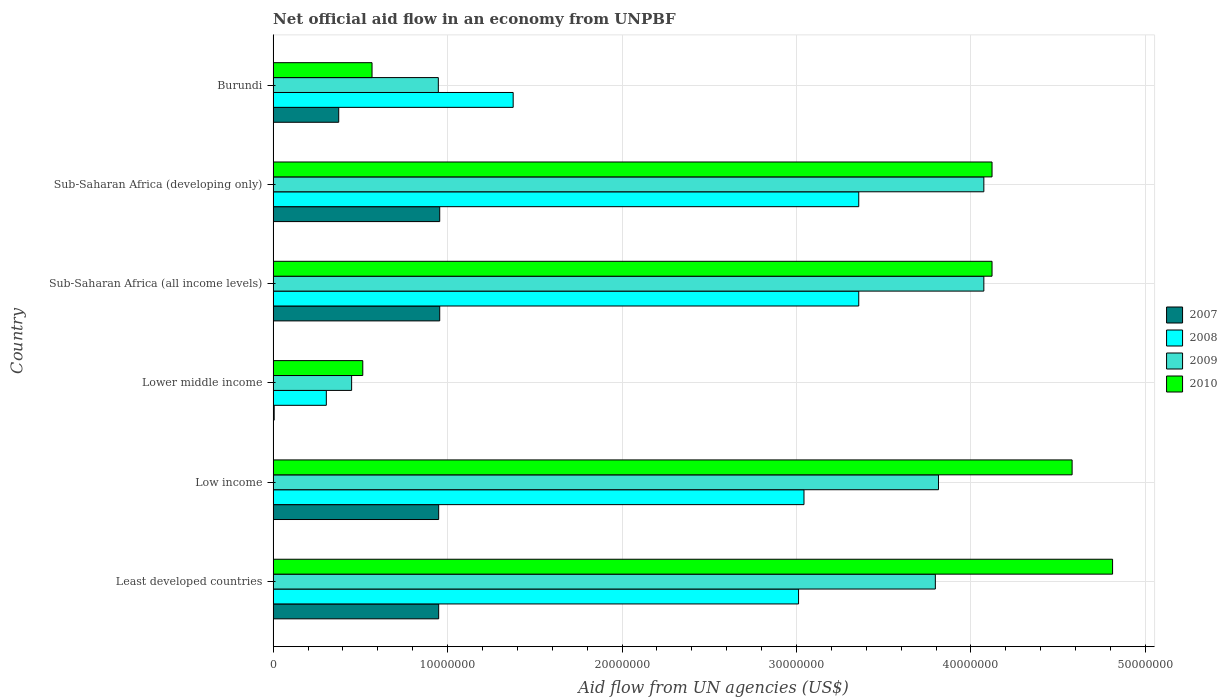What is the label of the 1st group of bars from the top?
Give a very brief answer. Burundi. In how many cases, is the number of bars for a given country not equal to the number of legend labels?
Ensure brevity in your answer.  0. What is the net official aid flow in 2007 in Lower middle income?
Make the answer very short. 6.00e+04. Across all countries, what is the maximum net official aid flow in 2010?
Your answer should be compact. 4.81e+07. Across all countries, what is the minimum net official aid flow in 2008?
Offer a very short reply. 3.05e+06. In which country was the net official aid flow in 2008 maximum?
Offer a very short reply. Sub-Saharan Africa (all income levels). In which country was the net official aid flow in 2008 minimum?
Provide a succinct answer. Lower middle income. What is the total net official aid flow in 2009 in the graph?
Ensure brevity in your answer.  1.72e+08. What is the difference between the net official aid flow in 2007 in Least developed countries and that in Low income?
Provide a succinct answer. 0. What is the difference between the net official aid flow in 2009 in Burundi and the net official aid flow in 2010 in Low income?
Keep it short and to the point. -3.63e+07. What is the average net official aid flow in 2008 per country?
Make the answer very short. 2.41e+07. What is the difference between the net official aid flow in 2010 and net official aid flow in 2008 in Sub-Saharan Africa (developing only)?
Make the answer very short. 7.64e+06. In how many countries, is the net official aid flow in 2007 greater than 48000000 US$?
Your answer should be very brief. 0. What is the ratio of the net official aid flow in 2010 in Low income to that in Sub-Saharan Africa (all income levels)?
Keep it short and to the point. 1.11. Is the difference between the net official aid flow in 2010 in Low income and Sub-Saharan Africa (developing only) greater than the difference between the net official aid flow in 2008 in Low income and Sub-Saharan Africa (developing only)?
Your answer should be very brief. Yes. What is the difference between the highest and the lowest net official aid flow in 2009?
Your answer should be compact. 3.62e+07. How many bars are there?
Your answer should be compact. 24. Are all the bars in the graph horizontal?
Provide a succinct answer. Yes. How many countries are there in the graph?
Make the answer very short. 6. Are the values on the major ticks of X-axis written in scientific E-notation?
Offer a very short reply. No. Does the graph contain grids?
Ensure brevity in your answer.  Yes. How many legend labels are there?
Provide a succinct answer. 4. How are the legend labels stacked?
Provide a short and direct response. Vertical. What is the title of the graph?
Give a very brief answer. Net official aid flow in an economy from UNPBF. Does "1981" appear as one of the legend labels in the graph?
Make the answer very short. No. What is the label or title of the X-axis?
Keep it short and to the point. Aid flow from UN agencies (US$). What is the Aid flow from UN agencies (US$) in 2007 in Least developed countries?
Keep it short and to the point. 9.49e+06. What is the Aid flow from UN agencies (US$) of 2008 in Least developed countries?
Your answer should be very brief. 3.01e+07. What is the Aid flow from UN agencies (US$) of 2009 in Least developed countries?
Make the answer very short. 3.80e+07. What is the Aid flow from UN agencies (US$) in 2010 in Least developed countries?
Ensure brevity in your answer.  4.81e+07. What is the Aid flow from UN agencies (US$) in 2007 in Low income?
Offer a very short reply. 9.49e+06. What is the Aid flow from UN agencies (US$) in 2008 in Low income?
Your answer should be compact. 3.04e+07. What is the Aid flow from UN agencies (US$) in 2009 in Low income?
Your answer should be very brief. 3.81e+07. What is the Aid flow from UN agencies (US$) in 2010 in Low income?
Offer a very short reply. 4.58e+07. What is the Aid flow from UN agencies (US$) in 2007 in Lower middle income?
Your response must be concise. 6.00e+04. What is the Aid flow from UN agencies (US$) in 2008 in Lower middle income?
Your answer should be very brief. 3.05e+06. What is the Aid flow from UN agencies (US$) of 2009 in Lower middle income?
Make the answer very short. 4.50e+06. What is the Aid flow from UN agencies (US$) of 2010 in Lower middle income?
Make the answer very short. 5.14e+06. What is the Aid flow from UN agencies (US$) of 2007 in Sub-Saharan Africa (all income levels)?
Your response must be concise. 9.55e+06. What is the Aid flow from UN agencies (US$) in 2008 in Sub-Saharan Africa (all income levels)?
Your answer should be very brief. 3.36e+07. What is the Aid flow from UN agencies (US$) of 2009 in Sub-Saharan Africa (all income levels)?
Offer a very short reply. 4.07e+07. What is the Aid flow from UN agencies (US$) of 2010 in Sub-Saharan Africa (all income levels)?
Your answer should be very brief. 4.12e+07. What is the Aid flow from UN agencies (US$) in 2007 in Sub-Saharan Africa (developing only)?
Ensure brevity in your answer.  9.55e+06. What is the Aid flow from UN agencies (US$) of 2008 in Sub-Saharan Africa (developing only)?
Offer a terse response. 3.36e+07. What is the Aid flow from UN agencies (US$) of 2009 in Sub-Saharan Africa (developing only)?
Offer a terse response. 4.07e+07. What is the Aid flow from UN agencies (US$) of 2010 in Sub-Saharan Africa (developing only)?
Ensure brevity in your answer.  4.12e+07. What is the Aid flow from UN agencies (US$) of 2007 in Burundi?
Offer a very short reply. 3.76e+06. What is the Aid flow from UN agencies (US$) in 2008 in Burundi?
Offer a terse response. 1.38e+07. What is the Aid flow from UN agencies (US$) of 2009 in Burundi?
Provide a short and direct response. 9.47e+06. What is the Aid flow from UN agencies (US$) of 2010 in Burundi?
Your answer should be very brief. 5.67e+06. Across all countries, what is the maximum Aid flow from UN agencies (US$) of 2007?
Offer a very short reply. 9.55e+06. Across all countries, what is the maximum Aid flow from UN agencies (US$) of 2008?
Give a very brief answer. 3.36e+07. Across all countries, what is the maximum Aid flow from UN agencies (US$) in 2009?
Ensure brevity in your answer.  4.07e+07. Across all countries, what is the maximum Aid flow from UN agencies (US$) of 2010?
Ensure brevity in your answer.  4.81e+07. Across all countries, what is the minimum Aid flow from UN agencies (US$) of 2008?
Make the answer very short. 3.05e+06. Across all countries, what is the minimum Aid flow from UN agencies (US$) of 2009?
Your answer should be very brief. 4.50e+06. Across all countries, what is the minimum Aid flow from UN agencies (US$) of 2010?
Provide a short and direct response. 5.14e+06. What is the total Aid flow from UN agencies (US$) in 2007 in the graph?
Your answer should be very brief. 4.19e+07. What is the total Aid flow from UN agencies (US$) in 2008 in the graph?
Your response must be concise. 1.44e+08. What is the total Aid flow from UN agencies (US$) in 2009 in the graph?
Offer a very short reply. 1.72e+08. What is the total Aid flow from UN agencies (US$) in 2010 in the graph?
Provide a short and direct response. 1.87e+08. What is the difference between the Aid flow from UN agencies (US$) in 2007 in Least developed countries and that in Low income?
Make the answer very short. 0. What is the difference between the Aid flow from UN agencies (US$) in 2008 in Least developed countries and that in Low income?
Your answer should be compact. -3.10e+05. What is the difference between the Aid flow from UN agencies (US$) of 2009 in Least developed countries and that in Low income?
Give a very brief answer. -1.80e+05. What is the difference between the Aid flow from UN agencies (US$) in 2010 in Least developed countries and that in Low income?
Your response must be concise. 2.32e+06. What is the difference between the Aid flow from UN agencies (US$) in 2007 in Least developed countries and that in Lower middle income?
Your answer should be compact. 9.43e+06. What is the difference between the Aid flow from UN agencies (US$) in 2008 in Least developed countries and that in Lower middle income?
Ensure brevity in your answer.  2.71e+07. What is the difference between the Aid flow from UN agencies (US$) in 2009 in Least developed countries and that in Lower middle income?
Your response must be concise. 3.35e+07. What is the difference between the Aid flow from UN agencies (US$) in 2010 in Least developed countries and that in Lower middle income?
Give a very brief answer. 4.30e+07. What is the difference between the Aid flow from UN agencies (US$) of 2008 in Least developed countries and that in Sub-Saharan Africa (all income levels)?
Your answer should be very brief. -3.45e+06. What is the difference between the Aid flow from UN agencies (US$) of 2009 in Least developed countries and that in Sub-Saharan Africa (all income levels)?
Your response must be concise. -2.78e+06. What is the difference between the Aid flow from UN agencies (US$) of 2010 in Least developed countries and that in Sub-Saharan Africa (all income levels)?
Give a very brief answer. 6.91e+06. What is the difference between the Aid flow from UN agencies (US$) of 2007 in Least developed countries and that in Sub-Saharan Africa (developing only)?
Your answer should be compact. -6.00e+04. What is the difference between the Aid flow from UN agencies (US$) of 2008 in Least developed countries and that in Sub-Saharan Africa (developing only)?
Give a very brief answer. -3.45e+06. What is the difference between the Aid flow from UN agencies (US$) of 2009 in Least developed countries and that in Sub-Saharan Africa (developing only)?
Your answer should be very brief. -2.78e+06. What is the difference between the Aid flow from UN agencies (US$) of 2010 in Least developed countries and that in Sub-Saharan Africa (developing only)?
Make the answer very short. 6.91e+06. What is the difference between the Aid flow from UN agencies (US$) of 2007 in Least developed countries and that in Burundi?
Offer a terse response. 5.73e+06. What is the difference between the Aid flow from UN agencies (US$) of 2008 in Least developed countries and that in Burundi?
Your response must be concise. 1.64e+07. What is the difference between the Aid flow from UN agencies (US$) of 2009 in Least developed countries and that in Burundi?
Your response must be concise. 2.85e+07. What is the difference between the Aid flow from UN agencies (US$) of 2010 in Least developed countries and that in Burundi?
Make the answer very short. 4.24e+07. What is the difference between the Aid flow from UN agencies (US$) of 2007 in Low income and that in Lower middle income?
Ensure brevity in your answer.  9.43e+06. What is the difference between the Aid flow from UN agencies (US$) of 2008 in Low income and that in Lower middle income?
Give a very brief answer. 2.74e+07. What is the difference between the Aid flow from UN agencies (US$) in 2009 in Low income and that in Lower middle income?
Your response must be concise. 3.36e+07. What is the difference between the Aid flow from UN agencies (US$) in 2010 in Low income and that in Lower middle income?
Make the answer very short. 4.07e+07. What is the difference between the Aid flow from UN agencies (US$) in 2008 in Low income and that in Sub-Saharan Africa (all income levels)?
Your answer should be very brief. -3.14e+06. What is the difference between the Aid flow from UN agencies (US$) of 2009 in Low income and that in Sub-Saharan Africa (all income levels)?
Offer a very short reply. -2.60e+06. What is the difference between the Aid flow from UN agencies (US$) in 2010 in Low income and that in Sub-Saharan Africa (all income levels)?
Provide a short and direct response. 4.59e+06. What is the difference between the Aid flow from UN agencies (US$) in 2007 in Low income and that in Sub-Saharan Africa (developing only)?
Offer a terse response. -6.00e+04. What is the difference between the Aid flow from UN agencies (US$) of 2008 in Low income and that in Sub-Saharan Africa (developing only)?
Provide a short and direct response. -3.14e+06. What is the difference between the Aid flow from UN agencies (US$) of 2009 in Low income and that in Sub-Saharan Africa (developing only)?
Ensure brevity in your answer.  -2.60e+06. What is the difference between the Aid flow from UN agencies (US$) of 2010 in Low income and that in Sub-Saharan Africa (developing only)?
Your answer should be compact. 4.59e+06. What is the difference between the Aid flow from UN agencies (US$) of 2007 in Low income and that in Burundi?
Offer a terse response. 5.73e+06. What is the difference between the Aid flow from UN agencies (US$) in 2008 in Low income and that in Burundi?
Keep it short and to the point. 1.67e+07. What is the difference between the Aid flow from UN agencies (US$) of 2009 in Low income and that in Burundi?
Offer a terse response. 2.87e+07. What is the difference between the Aid flow from UN agencies (US$) in 2010 in Low income and that in Burundi?
Your response must be concise. 4.01e+07. What is the difference between the Aid flow from UN agencies (US$) in 2007 in Lower middle income and that in Sub-Saharan Africa (all income levels)?
Offer a terse response. -9.49e+06. What is the difference between the Aid flow from UN agencies (US$) of 2008 in Lower middle income and that in Sub-Saharan Africa (all income levels)?
Make the answer very short. -3.05e+07. What is the difference between the Aid flow from UN agencies (US$) of 2009 in Lower middle income and that in Sub-Saharan Africa (all income levels)?
Your response must be concise. -3.62e+07. What is the difference between the Aid flow from UN agencies (US$) in 2010 in Lower middle income and that in Sub-Saharan Africa (all income levels)?
Your answer should be very brief. -3.61e+07. What is the difference between the Aid flow from UN agencies (US$) of 2007 in Lower middle income and that in Sub-Saharan Africa (developing only)?
Keep it short and to the point. -9.49e+06. What is the difference between the Aid flow from UN agencies (US$) in 2008 in Lower middle income and that in Sub-Saharan Africa (developing only)?
Provide a succinct answer. -3.05e+07. What is the difference between the Aid flow from UN agencies (US$) of 2009 in Lower middle income and that in Sub-Saharan Africa (developing only)?
Your answer should be very brief. -3.62e+07. What is the difference between the Aid flow from UN agencies (US$) in 2010 in Lower middle income and that in Sub-Saharan Africa (developing only)?
Make the answer very short. -3.61e+07. What is the difference between the Aid flow from UN agencies (US$) of 2007 in Lower middle income and that in Burundi?
Offer a very short reply. -3.70e+06. What is the difference between the Aid flow from UN agencies (US$) of 2008 in Lower middle income and that in Burundi?
Provide a short and direct response. -1.07e+07. What is the difference between the Aid flow from UN agencies (US$) in 2009 in Lower middle income and that in Burundi?
Your response must be concise. -4.97e+06. What is the difference between the Aid flow from UN agencies (US$) of 2010 in Lower middle income and that in Burundi?
Make the answer very short. -5.30e+05. What is the difference between the Aid flow from UN agencies (US$) in 2007 in Sub-Saharan Africa (all income levels) and that in Sub-Saharan Africa (developing only)?
Offer a terse response. 0. What is the difference between the Aid flow from UN agencies (US$) of 2008 in Sub-Saharan Africa (all income levels) and that in Sub-Saharan Africa (developing only)?
Keep it short and to the point. 0. What is the difference between the Aid flow from UN agencies (US$) of 2009 in Sub-Saharan Africa (all income levels) and that in Sub-Saharan Africa (developing only)?
Provide a short and direct response. 0. What is the difference between the Aid flow from UN agencies (US$) in 2007 in Sub-Saharan Africa (all income levels) and that in Burundi?
Make the answer very short. 5.79e+06. What is the difference between the Aid flow from UN agencies (US$) in 2008 in Sub-Saharan Africa (all income levels) and that in Burundi?
Provide a succinct answer. 1.98e+07. What is the difference between the Aid flow from UN agencies (US$) in 2009 in Sub-Saharan Africa (all income levels) and that in Burundi?
Your answer should be very brief. 3.13e+07. What is the difference between the Aid flow from UN agencies (US$) of 2010 in Sub-Saharan Africa (all income levels) and that in Burundi?
Your answer should be compact. 3.55e+07. What is the difference between the Aid flow from UN agencies (US$) of 2007 in Sub-Saharan Africa (developing only) and that in Burundi?
Give a very brief answer. 5.79e+06. What is the difference between the Aid flow from UN agencies (US$) of 2008 in Sub-Saharan Africa (developing only) and that in Burundi?
Offer a very short reply. 1.98e+07. What is the difference between the Aid flow from UN agencies (US$) of 2009 in Sub-Saharan Africa (developing only) and that in Burundi?
Keep it short and to the point. 3.13e+07. What is the difference between the Aid flow from UN agencies (US$) of 2010 in Sub-Saharan Africa (developing only) and that in Burundi?
Your answer should be compact. 3.55e+07. What is the difference between the Aid flow from UN agencies (US$) of 2007 in Least developed countries and the Aid flow from UN agencies (US$) of 2008 in Low income?
Provide a short and direct response. -2.09e+07. What is the difference between the Aid flow from UN agencies (US$) in 2007 in Least developed countries and the Aid flow from UN agencies (US$) in 2009 in Low income?
Ensure brevity in your answer.  -2.86e+07. What is the difference between the Aid flow from UN agencies (US$) of 2007 in Least developed countries and the Aid flow from UN agencies (US$) of 2010 in Low income?
Provide a short and direct response. -3.63e+07. What is the difference between the Aid flow from UN agencies (US$) of 2008 in Least developed countries and the Aid flow from UN agencies (US$) of 2009 in Low income?
Make the answer very short. -8.02e+06. What is the difference between the Aid flow from UN agencies (US$) in 2008 in Least developed countries and the Aid flow from UN agencies (US$) in 2010 in Low income?
Provide a succinct answer. -1.57e+07. What is the difference between the Aid flow from UN agencies (US$) of 2009 in Least developed countries and the Aid flow from UN agencies (US$) of 2010 in Low income?
Your answer should be compact. -7.84e+06. What is the difference between the Aid flow from UN agencies (US$) of 2007 in Least developed countries and the Aid flow from UN agencies (US$) of 2008 in Lower middle income?
Keep it short and to the point. 6.44e+06. What is the difference between the Aid flow from UN agencies (US$) in 2007 in Least developed countries and the Aid flow from UN agencies (US$) in 2009 in Lower middle income?
Provide a short and direct response. 4.99e+06. What is the difference between the Aid flow from UN agencies (US$) in 2007 in Least developed countries and the Aid flow from UN agencies (US$) in 2010 in Lower middle income?
Provide a short and direct response. 4.35e+06. What is the difference between the Aid flow from UN agencies (US$) of 2008 in Least developed countries and the Aid flow from UN agencies (US$) of 2009 in Lower middle income?
Keep it short and to the point. 2.56e+07. What is the difference between the Aid flow from UN agencies (US$) in 2008 in Least developed countries and the Aid flow from UN agencies (US$) in 2010 in Lower middle income?
Provide a succinct answer. 2.50e+07. What is the difference between the Aid flow from UN agencies (US$) in 2009 in Least developed countries and the Aid flow from UN agencies (US$) in 2010 in Lower middle income?
Keep it short and to the point. 3.28e+07. What is the difference between the Aid flow from UN agencies (US$) of 2007 in Least developed countries and the Aid flow from UN agencies (US$) of 2008 in Sub-Saharan Africa (all income levels)?
Make the answer very short. -2.41e+07. What is the difference between the Aid flow from UN agencies (US$) in 2007 in Least developed countries and the Aid flow from UN agencies (US$) in 2009 in Sub-Saharan Africa (all income levels)?
Ensure brevity in your answer.  -3.12e+07. What is the difference between the Aid flow from UN agencies (US$) of 2007 in Least developed countries and the Aid flow from UN agencies (US$) of 2010 in Sub-Saharan Africa (all income levels)?
Keep it short and to the point. -3.17e+07. What is the difference between the Aid flow from UN agencies (US$) of 2008 in Least developed countries and the Aid flow from UN agencies (US$) of 2009 in Sub-Saharan Africa (all income levels)?
Your answer should be very brief. -1.06e+07. What is the difference between the Aid flow from UN agencies (US$) in 2008 in Least developed countries and the Aid flow from UN agencies (US$) in 2010 in Sub-Saharan Africa (all income levels)?
Offer a very short reply. -1.11e+07. What is the difference between the Aid flow from UN agencies (US$) of 2009 in Least developed countries and the Aid flow from UN agencies (US$) of 2010 in Sub-Saharan Africa (all income levels)?
Offer a very short reply. -3.25e+06. What is the difference between the Aid flow from UN agencies (US$) in 2007 in Least developed countries and the Aid flow from UN agencies (US$) in 2008 in Sub-Saharan Africa (developing only)?
Keep it short and to the point. -2.41e+07. What is the difference between the Aid flow from UN agencies (US$) of 2007 in Least developed countries and the Aid flow from UN agencies (US$) of 2009 in Sub-Saharan Africa (developing only)?
Ensure brevity in your answer.  -3.12e+07. What is the difference between the Aid flow from UN agencies (US$) of 2007 in Least developed countries and the Aid flow from UN agencies (US$) of 2010 in Sub-Saharan Africa (developing only)?
Your answer should be compact. -3.17e+07. What is the difference between the Aid flow from UN agencies (US$) in 2008 in Least developed countries and the Aid flow from UN agencies (US$) in 2009 in Sub-Saharan Africa (developing only)?
Offer a terse response. -1.06e+07. What is the difference between the Aid flow from UN agencies (US$) of 2008 in Least developed countries and the Aid flow from UN agencies (US$) of 2010 in Sub-Saharan Africa (developing only)?
Provide a short and direct response. -1.11e+07. What is the difference between the Aid flow from UN agencies (US$) of 2009 in Least developed countries and the Aid flow from UN agencies (US$) of 2010 in Sub-Saharan Africa (developing only)?
Give a very brief answer. -3.25e+06. What is the difference between the Aid flow from UN agencies (US$) in 2007 in Least developed countries and the Aid flow from UN agencies (US$) in 2008 in Burundi?
Your response must be concise. -4.27e+06. What is the difference between the Aid flow from UN agencies (US$) of 2007 in Least developed countries and the Aid flow from UN agencies (US$) of 2010 in Burundi?
Offer a very short reply. 3.82e+06. What is the difference between the Aid flow from UN agencies (US$) in 2008 in Least developed countries and the Aid flow from UN agencies (US$) in 2009 in Burundi?
Provide a succinct answer. 2.06e+07. What is the difference between the Aid flow from UN agencies (US$) in 2008 in Least developed countries and the Aid flow from UN agencies (US$) in 2010 in Burundi?
Make the answer very short. 2.44e+07. What is the difference between the Aid flow from UN agencies (US$) in 2009 in Least developed countries and the Aid flow from UN agencies (US$) in 2010 in Burundi?
Your answer should be compact. 3.23e+07. What is the difference between the Aid flow from UN agencies (US$) of 2007 in Low income and the Aid flow from UN agencies (US$) of 2008 in Lower middle income?
Keep it short and to the point. 6.44e+06. What is the difference between the Aid flow from UN agencies (US$) of 2007 in Low income and the Aid flow from UN agencies (US$) of 2009 in Lower middle income?
Your response must be concise. 4.99e+06. What is the difference between the Aid flow from UN agencies (US$) in 2007 in Low income and the Aid flow from UN agencies (US$) in 2010 in Lower middle income?
Give a very brief answer. 4.35e+06. What is the difference between the Aid flow from UN agencies (US$) of 2008 in Low income and the Aid flow from UN agencies (US$) of 2009 in Lower middle income?
Provide a succinct answer. 2.59e+07. What is the difference between the Aid flow from UN agencies (US$) in 2008 in Low income and the Aid flow from UN agencies (US$) in 2010 in Lower middle income?
Your response must be concise. 2.53e+07. What is the difference between the Aid flow from UN agencies (US$) in 2009 in Low income and the Aid flow from UN agencies (US$) in 2010 in Lower middle income?
Offer a terse response. 3.30e+07. What is the difference between the Aid flow from UN agencies (US$) in 2007 in Low income and the Aid flow from UN agencies (US$) in 2008 in Sub-Saharan Africa (all income levels)?
Keep it short and to the point. -2.41e+07. What is the difference between the Aid flow from UN agencies (US$) of 2007 in Low income and the Aid flow from UN agencies (US$) of 2009 in Sub-Saharan Africa (all income levels)?
Provide a succinct answer. -3.12e+07. What is the difference between the Aid flow from UN agencies (US$) in 2007 in Low income and the Aid flow from UN agencies (US$) in 2010 in Sub-Saharan Africa (all income levels)?
Provide a short and direct response. -3.17e+07. What is the difference between the Aid flow from UN agencies (US$) of 2008 in Low income and the Aid flow from UN agencies (US$) of 2009 in Sub-Saharan Africa (all income levels)?
Provide a short and direct response. -1.03e+07. What is the difference between the Aid flow from UN agencies (US$) of 2008 in Low income and the Aid flow from UN agencies (US$) of 2010 in Sub-Saharan Africa (all income levels)?
Offer a very short reply. -1.08e+07. What is the difference between the Aid flow from UN agencies (US$) in 2009 in Low income and the Aid flow from UN agencies (US$) in 2010 in Sub-Saharan Africa (all income levels)?
Provide a succinct answer. -3.07e+06. What is the difference between the Aid flow from UN agencies (US$) of 2007 in Low income and the Aid flow from UN agencies (US$) of 2008 in Sub-Saharan Africa (developing only)?
Your response must be concise. -2.41e+07. What is the difference between the Aid flow from UN agencies (US$) in 2007 in Low income and the Aid flow from UN agencies (US$) in 2009 in Sub-Saharan Africa (developing only)?
Give a very brief answer. -3.12e+07. What is the difference between the Aid flow from UN agencies (US$) in 2007 in Low income and the Aid flow from UN agencies (US$) in 2010 in Sub-Saharan Africa (developing only)?
Your answer should be compact. -3.17e+07. What is the difference between the Aid flow from UN agencies (US$) of 2008 in Low income and the Aid flow from UN agencies (US$) of 2009 in Sub-Saharan Africa (developing only)?
Give a very brief answer. -1.03e+07. What is the difference between the Aid flow from UN agencies (US$) in 2008 in Low income and the Aid flow from UN agencies (US$) in 2010 in Sub-Saharan Africa (developing only)?
Keep it short and to the point. -1.08e+07. What is the difference between the Aid flow from UN agencies (US$) in 2009 in Low income and the Aid flow from UN agencies (US$) in 2010 in Sub-Saharan Africa (developing only)?
Offer a terse response. -3.07e+06. What is the difference between the Aid flow from UN agencies (US$) in 2007 in Low income and the Aid flow from UN agencies (US$) in 2008 in Burundi?
Provide a succinct answer. -4.27e+06. What is the difference between the Aid flow from UN agencies (US$) of 2007 in Low income and the Aid flow from UN agencies (US$) of 2009 in Burundi?
Provide a short and direct response. 2.00e+04. What is the difference between the Aid flow from UN agencies (US$) of 2007 in Low income and the Aid flow from UN agencies (US$) of 2010 in Burundi?
Offer a terse response. 3.82e+06. What is the difference between the Aid flow from UN agencies (US$) in 2008 in Low income and the Aid flow from UN agencies (US$) in 2009 in Burundi?
Give a very brief answer. 2.10e+07. What is the difference between the Aid flow from UN agencies (US$) in 2008 in Low income and the Aid flow from UN agencies (US$) in 2010 in Burundi?
Provide a short and direct response. 2.48e+07. What is the difference between the Aid flow from UN agencies (US$) of 2009 in Low income and the Aid flow from UN agencies (US$) of 2010 in Burundi?
Ensure brevity in your answer.  3.25e+07. What is the difference between the Aid flow from UN agencies (US$) in 2007 in Lower middle income and the Aid flow from UN agencies (US$) in 2008 in Sub-Saharan Africa (all income levels)?
Provide a short and direct response. -3.35e+07. What is the difference between the Aid flow from UN agencies (US$) of 2007 in Lower middle income and the Aid flow from UN agencies (US$) of 2009 in Sub-Saharan Africa (all income levels)?
Ensure brevity in your answer.  -4.07e+07. What is the difference between the Aid flow from UN agencies (US$) in 2007 in Lower middle income and the Aid flow from UN agencies (US$) in 2010 in Sub-Saharan Africa (all income levels)?
Offer a terse response. -4.12e+07. What is the difference between the Aid flow from UN agencies (US$) in 2008 in Lower middle income and the Aid flow from UN agencies (US$) in 2009 in Sub-Saharan Africa (all income levels)?
Ensure brevity in your answer.  -3.77e+07. What is the difference between the Aid flow from UN agencies (US$) of 2008 in Lower middle income and the Aid flow from UN agencies (US$) of 2010 in Sub-Saharan Africa (all income levels)?
Your answer should be very brief. -3.82e+07. What is the difference between the Aid flow from UN agencies (US$) of 2009 in Lower middle income and the Aid flow from UN agencies (US$) of 2010 in Sub-Saharan Africa (all income levels)?
Your answer should be compact. -3.67e+07. What is the difference between the Aid flow from UN agencies (US$) in 2007 in Lower middle income and the Aid flow from UN agencies (US$) in 2008 in Sub-Saharan Africa (developing only)?
Provide a short and direct response. -3.35e+07. What is the difference between the Aid flow from UN agencies (US$) of 2007 in Lower middle income and the Aid flow from UN agencies (US$) of 2009 in Sub-Saharan Africa (developing only)?
Your answer should be very brief. -4.07e+07. What is the difference between the Aid flow from UN agencies (US$) in 2007 in Lower middle income and the Aid flow from UN agencies (US$) in 2010 in Sub-Saharan Africa (developing only)?
Give a very brief answer. -4.12e+07. What is the difference between the Aid flow from UN agencies (US$) of 2008 in Lower middle income and the Aid flow from UN agencies (US$) of 2009 in Sub-Saharan Africa (developing only)?
Make the answer very short. -3.77e+07. What is the difference between the Aid flow from UN agencies (US$) in 2008 in Lower middle income and the Aid flow from UN agencies (US$) in 2010 in Sub-Saharan Africa (developing only)?
Provide a succinct answer. -3.82e+07. What is the difference between the Aid flow from UN agencies (US$) in 2009 in Lower middle income and the Aid flow from UN agencies (US$) in 2010 in Sub-Saharan Africa (developing only)?
Your answer should be compact. -3.67e+07. What is the difference between the Aid flow from UN agencies (US$) of 2007 in Lower middle income and the Aid flow from UN agencies (US$) of 2008 in Burundi?
Your answer should be compact. -1.37e+07. What is the difference between the Aid flow from UN agencies (US$) of 2007 in Lower middle income and the Aid flow from UN agencies (US$) of 2009 in Burundi?
Keep it short and to the point. -9.41e+06. What is the difference between the Aid flow from UN agencies (US$) of 2007 in Lower middle income and the Aid flow from UN agencies (US$) of 2010 in Burundi?
Offer a very short reply. -5.61e+06. What is the difference between the Aid flow from UN agencies (US$) in 2008 in Lower middle income and the Aid flow from UN agencies (US$) in 2009 in Burundi?
Provide a short and direct response. -6.42e+06. What is the difference between the Aid flow from UN agencies (US$) of 2008 in Lower middle income and the Aid flow from UN agencies (US$) of 2010 in Burundi?
Keep it short and to the point. -2.62e+06. What is the difference between the Aid flow from UN agencies (US$) in 2009 in Lower middle income and the Aid flow from UN agencies (US$) in 2010 in Burundi?
Give a very brief answer. -1.17e+06. What is the difference between the Aid flow from UN agencies (US$) in 2007 in Sub-Saharan Africa (all income levels) and the Aid flow from UN agencies (US$) in 2008 in Sub-Saharan Africa (developing only)?
Provide a short and direct response. -2.40e+07. What is the difference between the Aid flow from UN agencies (US$) of 2007 in Sub-Saharan Africa (all income levels) and the Aid flow from UN agencies (US$) of 2009 in Sub-Saharan Africa (developing only)?
Offer a very short reply. -3.12e+07. What is the difference between the Aid flow from UN agencies (US$) of 2007 in Sub-Saharan Africa (all income levels) and the Aid flow from UN agencies (US$) of 2010 in Sub-Saharan Africa (developing only)?
Provide a short and direct response. -3.17e+07. What is the difference between the Aid flow from UN agencies (US$) of 2008 in Sub-Saharan Africa (all income levels) and the Aid flow from UN agencies (US$) of 2009 in Sub-Saharan Africa (developing only)?
Ensure brevity in your answer.  -7.17e+06. What is the difference between the Aid flow from UN agencies (US$) in 2008 in Sub-Saharan Africa (all income levels) and the Aid flow from UN agencies (US$) in 2010 in Sub-Saharan Africa (developing only)?
Provide a short and direct response. -7.64e+06. What is the difference between the Aid flow from UN agencies (US$) in 2009 in Sub-Saharan Africa (all income levels) and the Aid flow from UN agencies (US$) in 2010 in Sub-Saharan Africa (developing only)?
Provide a succinct answer. -4.70e+05. What is the difference between the Aid flow from UN agencies (US$) in 2007 in Sub-Saharan Africa (all income levels) and the Aid flow from UN agencies (US$) in 2008 in Burundi?
Your response must be concise. -4.21e+06. What is the difference between the Aid flow from UN agencies (US$) in 2007 in Sub-Saharan Africa (all income levels) and the Aid flow from UN agencies (US$) in 2010 in Burundi?
Provide a short and direct response. 3.88e+06. What is the difference between the Aid flow from UN agencies (US$) in 2008 in Sub-Saharan Africa (all income levels) and the Aid flow from UN agencies (US$) in 2009 in Burundi?
Your response must be concise. 2.41e+07. What is the difference between the Aid flow from UN agencies (US$) of 2008 in Sub-Saharan Africa (all income levels) and the Aid flow from UN agencies (US$) of 2010 in Burundi?
Your answer should be very brief. 2.79e+07. What is the difference between the Aid flow from UN agencies (US$) of 2009 in Sub-Saharan Africa (all income levels) and the Aid flow from UN agencies (US$) of 2010 in Burundi?
Keep it short and to the point. 3.51e+07. What is the difference between the Aid flow from UN agencies (US$) in 2007 in Sub-Saharan Africa (developing only) and the Aid flow from UN agencies (US$) in 2008 in Burundi?
Your answer should be compact. -4.21e+06. What is the difference between the Aid flow from UN agencies (US$) in 2007 in Sub-Saharan Africa (developing only) and the Aid flow from UN agencies (US$) in 2010 in Burundi?
Make the answer very short. 3.88e+06. What is the difference between the Aid flow from UN agencies (US$) of 2008 in Sub-Saharan Africa (developing only) and the Aid flow from UN agencies (US$) of 2009 in Burundi?
Your response must be concise. 2.41e+07. What is the difference between the Aid flow from UN agencies (US$) of 2008 in Sub-Saharan Africa (developing only) and the Aid flow from UN agencies (US$) of 2010 in Burundi?
Make the answer very short. 2.79e+07. What is the difference between the Aid flow from UN agencies (US$) of 2009 in Sub-Saharan Africa (developing only) and the Aid flow from UN agencies (US$) of 2010 in Burundi?
Your answer should be very brief. 3.51e+07. What is the average Aid flow from UN agencies (US$) of 2007 per country?
Provide a short and direct response. 6.98e+06. What is the average Aid flow from UN agencies (US$) in 2008 per country?
Provide a succinct answer. 2.41e+07. What is the average Aid flow from UN agencies (US$) in 2009 per country?
Ensure brevity in your answer.  2.86e+07. What is the average Aid flow from UN agencies (US$) in 2010 per country?
Your answer should be compact. 3.12e+07. What is the difference between the Aid flow from UN agencies (US$) in 2007 and Aid flow from UN agencies (US$) in 2008 in Least developed countries?
Give a very brief answer. -2.06e+07. What is the difference between the Aid flow from UN agencies (US$) in 2007 and Aid flow from UN agencies (US$) in 2009 in Least developed countries?
Your response must be concise. -2.85e+07. What is the difference between the Aid flow from UN agencies (US$) of 2007 and Aid flow from UN agencies (US$) of 2010 in Least developed countries?
Ensure brevity in your answer.  -3.86e+07. What is the difference between the Aid flow from UN agencies (US$) in 2008 and Aid flow from UN agencies (US$) in 2009 in Least developed countries?
Provide a succinct answer. -7.84e+06. What is the difference between the Aid flow from UN agencies (US$) of 2008 and Aid flow from UN agencies (US$) of 2010 in Least developed countries?
Ensure brevity in your answer.  -1.80e+07. What is the difference between the Aid flow from UN agencies (US$) of 2009 and Aid flow from UN agencies (US$) of 2010 in Least developed countries?
Give a very brief answer. -1.02e+07. What is the difference between the Aid flow from UN agencies (US$) of 2007 and Aid flow from UN agencies (US$) of 2008 in Low income?
Your answer should be compact. -2.09e+07. What is the difference between the Aid flow from UN agencies (US$) of 2007 and Aid flow from UN agencies (US$) of 2009 in Low income?
Your answer should be compact. -2.86e+07. What is the difference between the Aid flow from UN agencies (US$) of 2007 and Aid flow from UN agencies (US$) of 2010 in Low income?
Keep it short and to the point. -3.63e+07. What is the difference between the Aid flow from UN agencies (US$) of 2008 and Aid flow from UN agencies (US$) of 2009 in Low income?
Provide a short and direct response. -7.71e+06. What is the difference between the Aid flow from UN agencies (US$) of 2008 and Aid flow from UN agencies (US$) of 2010 in Low income?
Provide a succinct answer. -1.54e+07. What is the difference between the Aid flow from UN agencies (US$) of 2009 and Aid flow from UN agencies (US$) of 2010 in Low income?
Make the answer very short. -7.66e+06. What is the difference between the Aid flow from UN agencies (US$) of 2007 and Aid flow from UN agencies (US$) of 2008 in Lower middle income?
Keep it short and to the point. -2.99e+06. What is the difference between the Aid flow from UN agencies (US$) of 2007 and Aid flow from UN agencies (US$) of 2009 in Lower middle income?
Provide a short and direct response. -4.44e+06. What is the difference between the Aid flow from UN agencies (US$) in 2007 and Aid flow from UN agencies (US$) in 2010 in Lower middle income?
Your answer should be very brief. -5.08e+06. What is the difference between the Aid flow from UN agencies (US$) in 2008 and Aid flow from UN agencies (US$) in 2009 in Lower middle income?
Your response must be concise. -1.45e+06. What is the difference between the Aid flow from UN agencies (US$) of 2008 and Aid flow from UN agencies (US$) of 2010 in Lower middle income?
Your answer should be very brief. -2.09e+06. What is the difference between the Aid flow from UN agencies (US$) in 2009 and Aid flow from UN agencies (US$) in 2010 in Lower middle income?
Ensure brevity in your answer.  -6.40e+05. What is the difference between the Aid flow from UN agencies (US$) in 2007 and Aid flow from UN agencies (US$) in 2008 in Sub-Saharan Africa (all income levels)?
Keep it short and to the point. -2.40e+07. What is the difference between the Aid flow from UN agencies (US$) in 2007 and Aid flow from UN agencies (US$) in 2009 in Sub-Saharan Africa (all income levels)?
Your response must be concise. -3.12e+07. What is the difference between the Aid flow from UN agencies (US$) in 2007 and Aid flow from UN agencies (US$) in 2010 in Sub-Saharan Africa (all income levels)?
Offer a terse response. -3.17e+07. What is the difference between the Aid flow from UN agencies (US$) of 2008 and Aid flow from UN agencies (US$) of 2009 in Sub-Saharan Africa (all income levels)?
Ensure brevity in your answer.  -7.17e+06. What is the difference between the Aid flow from UN agencies (US$) of 2008 and Aid flow from UN agencies (US$) of 2010 in Sub-Saharan Africa (all income levels)?
Offer a very short reply. -7.64e+06. What is the difference between the Aid flow from UN agencies (US$) of 2009 and Aid flow from UN agencies (US$) of 2010 in Sub-Saharan Africa (all income levels)?
Provide a short and direct response. -4.70e+05. What is the difference between the Aid flow from UN agencies (US$) in 2007 and Aid flow from UN agencies (US$) in 2008 in Sub-Saharan Africa (developing only)?
Keep it short and to the point. -2.40e+07. What is the difference between the Aid flow from UN agencies (US$) in 2007 and Aid flow from UN agencies (US$) in 2009 in Sub-Saharan Africa (developing only)?
Your answer should be compact. -3.12e+07. What is the difference between the Aid flow from UN agencies (US$) of 2007 and Aid flow from UN agencies (US$) of 2010 in Sub-Saharan Africa (developing only)?
Your answer should be compact. -3.17e+07. What is the difference between the Aid flow from UN agencies (US$) in 2008 and Aid flow from UN agencies (US$) in 2009 in Sub-Saharan Africa (developing only)?
Offer a terse response. -7.17e+06. What is the difference between the Aid flow from UN agencies (US$) of 2008 and Aid flow from UN agencies (US$) of 2010 in Sub-Saharan Africa (developing only)?
Give a very brief answer. -7.64e+06. What is the difference between the Aid flow from UN agencies (US$) of 2009 and Aid flow from UN agencies (US$) of 2010 in Sub-Saharan Africa (developing only)?
Keep it short and to the point. -4.70e+05. What is the difference between the Aid flow from UN agencies (US$) in 2007 and Aid flow from UN agencies (US$) in 2008 in Burundi?
Ensure brevity in your answer.  -1.00e+07. What is the difference between the Aid flow from UN agencies (US$) of 2007 and Aid flow from UN agencies (US$) of 2009 in Burundi?
Make the answer very short. -5.71e+06. What is the difference between the Aid flow from UN agencies (US$) in 2007 and Aid flow from UN agencies (US$) in 2010 in Burundi?
Make the answer very short. -1.91e+06. What is the difference between the Aid flow from UN agencies (US$) of 2008 and Aid flow from UN agencies (US$) of 2009 in Burundi?
Your answer should be compact. 4.29e+06. What is the difference between the Aid flow from UN agencies (US$) of 2008 and Aid flow from UN agencies (US$) of 2010 in Burundi?
Your response must be concise. 8.09e+06. What is the difference between the Aid flow from UN agencies (US$) in 2009 and Aid flow from UN agencies (US$) in 2010 in Burundi?
Your answer should be compact. 3.80e+06. What is the ratio of the Aid flow from UN agencies (US$) in 2009 in Least developed countries to that in Low income?
Ensure brevity in your answer.  1. What is the ratio of the Aid flow from UN agencies (US$) in 2010 in Least developed countries to that in Low income?
Your answer should be compact. 1.05. What is the ratio of the Aid flow from UN agencies (US$) in 2007 in Least developed countries to that in Lower middle income?
Offer a terse response. 158.17. What is the ratio of the Aid flow from UN agencies (US$) of 2008 in Least developed countries to that in Lower middle income?
Your answer should be compact. 9.88. What is the ratio of the Aid flow from UN agencies (US$) in 2009 in Least developed countries to that in Lower middle income?
Your response must be concise. 8.44. What is the ratio of the Aid flow from UN agencies (US$) in 2010 in Least developed countries to that in Lower middle income?
Make the answer very short. 9.36. What is the ratio of the Aid flow from UN agencies (US$) in 2008 in Least developed countries to that in Sub-Saharan Africa (all income levels)?
Give a very brief answer. 0.9. What is the ratio of the Aid flow from UN agencies (US$) of 2009 in Least developed countries to that in Sub-Saharan Africa (all income levels)?
Your answer should be very brief. 0.93. What is the ratio of the Aid flow from UN agencies (US$) in 2010 in Least developed countries to that in Sub-Saharan Africa (all income levels)?
Your response must be concise. 1.17. What is the ratio of the Aid flow from UN agencies (US$) in 2008 in Least developed countries to that in Sub-Saharan Africa (developing only)?
Offer a very short reply. 0.9. What is the ratio of the Aid flow from UN agencies (US$) of 2009 in Least developed countries to that in Sub-Saharan Africa (developing only)?
Your answer should be very brief. 0.93. What is the ratio of the Aid flow from UN agencies (US$) of 2010 in Least developed countries to that in Sub-Saharan Africa (developing only)?
Your response must be concise. 1.17. What is the ratio of the Aid flow from UN agencies (US$) in 2007 in Least developed countries to that in Burundi?
Make the answer very short. 2.52. What is the ratio of the Aid flow from UN agencies (US$) in 2008 in Least developed countries to that in Burundi?
Your answer should be compact. 2.19. What is the ratio of the Aid flow from UN agencies (US$) of 2009 in Least developed countries to that in Burundi?
Offer a very short reply. 4.01. What is the ratio of the Aid flow from UN agencies (US$) in 2010 in Least developed countries to that in Burundi?
Your answer should be compact. 8.49. What is the ratio of the Aid flow from UN agencies (US$) of 2007 in Low income to that in Lower middle income?
Your answer should be very brief. 158.17. What is the ratio of the Aid flow from UN agencies (US$) of 2008 in Low income to that in Lower middle income?
Make the answer very short. 9.98. What is the ratio of the Aid flow from UN agencies (US$) of 2009 in Low income to that in Lower middle income?
Your answer should be very brief. 8.48. What is the ratio of the Aid flow from UN agencies (US$) in 2010 in Low income to that in Lower middle income?
Provide a succinct answer. 8.91. What is the ratio of the Aid flow from UN agencies (US$) of 2008 in Low income to that in Sub-Saharan Africa (all income levels)?
Offer a terse response. 0.91. What is the ratio of the Aid flow from UN agencies (US$) of 2009 in Low income to that in Sub-Saharan Africa (all income levels)?
Offer a very short reply. 0.94. What is the ratio of the Aid flow from UN agencies (US$) in 2010 in Low income to that in Sub-Saharan Africa (all income levels)?
Ensure brevity in your answer.  1.11. What is the ratio of the Aid flow from UN agencies (US$) in 2008 in Low income to that in Sub-Saharan Africa (developing only)?
Your answer should be compact. 0.91. What is the ratio of the Aid flow from UN agencies (US$) in 2009 in Low income to that in Sub-Saharan Africa (developing only)?
Provide a succinct answer. 0.94. What is the ratio of the Aid flow from UN agencies (US$) in 2010 in Low income to that in Sub-Saharan Africa (developing only)?
Offer a terse response. 1.11. What is the ratio of the Aid flow from UN agencies (US$) in 2007 in Low income to that in Burundi?
Provide a succinct answer. 2.52. What is the ratio of the Aid flow from UN agencies (US$) in 2008 in Low income to that in Burundi?
Keep it short and to the point. 2.21. What is the ratio of the Aid flow from UN agencies (US$) of 2009 in Low income to that in Burundi?
Offer a very short reply. 4.03. What is the ratio of the Aid flow from UN agencies (US$) in 2010 in Low income to that in Burundi?
Your answer should be compact. 8.08. What is the ratio of the Aid flow from UN agencies (US$) in 2007 in Lower middle income to that in Sub-Saharan Africa (all income levels)?
Offer a very short reply. 0.01. What is the ratio of the Aid flow from UN agencies (US$) in 2008 in Lower middle income to that in Sub-Saharan Africa (all income levels)?
Your response must be concise. 0.09. What is the ratio of the Aid flow from UN agencies (US$) in 2009 in Lower middle income to that in Sub-Saharan Africa (all income levels)?
Your answer should be compact. 0.11. What is the ratio of the Aid flow from UN agencies (US$) of 2010 in Lower middle income to that in Sub-Saharan Africa (all income levels)?
Ensure brevity in your answer.  0.12. What is the ratio of the Aid flow from UN agencies (US$) of 2007 in Lower middle income to that in Sub-Saharan Africa (developing only)?
Keep it short and to the point. 0.01. What is the ratio of the Aid flow from UN agencies (US$) in 2008 in Lower middle income to that in Sub-Saharan Africa (developing only)?
Keep it short and to the point. 0.09. What is the ratio of the Aid flow from UN agencies (US$) in 2009 in Lower middle income to that in Sub-Saharan Africa (developing only)?
Provide a short and direct response. 0.11. What is the ratio of the Aid flow from UN agencies (US$) in 2010 in Lower middle income to that in Sub-Saharan Africa (developing only)?
Your answer should be very brief. 0.12. What is the ratio of the Aid flow from UN agencies (US$) in 2007 in Lower middle income to that in Burundi?
Your response must be concise. 0.02. What is the ratio of the Aid flow from UN agencies (US$) in 2008 in Lower middle income to that in Burundi?
Your answer should be very brief. 0.22. What is the ratio of the Aid flow from UN agencies (US$) of 2009 in Lower middle income to that in Burundi?
Offer a very short reply. 0.48. What is the ratio of the Aid flow from UN agencies (US$) in 2010 in Lower middle income to that in Burundi?
Give a very brief answer. 0.91. What is the ratio of the Aid flow from UN agencies (US$) of 2007 in Sub-Saharan Africa (all income levels) to that in Sub-Saharan Africa (developing only)?
Make the answer very short. 1. What is the ratio of the Aid flow from UN agencies (US$) of 2008 in Sub-Saharan Africa (all income levels) to that in Sub-Saharan Africa (developing only)?
Ensure brevity in your answer.  1. What is the ratio of the Aid flow from UN agencies (US$) in 2009 in Sub-Saharan Africa (all income levels) to that in Sub-Saharan Africa (developing only)?
Ensure brevity in your answer.  1. What is the ratio of the Aid flow from UN agencies (US$) of 2007 in Sub-Saharan Africa (all income levels) to that in Burundi?
Offer a terse response. 2.54. What is the ratio of the Aid flow from UN agencies (US$) in 2008 in Sub-Saharan Africa (all income levels) to that in Burundi?
Offer a very short reply. 2.44. What is the ratio of the Aid flow from UN agencies (US$) of 2009 in Sub-Saharan Africa (all income levels) to that in Burundi?
Your answer should be very brief. 4.3. What is the ratio of the Aid flow from UN agencies (US$) of 2010 in Sub-Saharan Africa (all income levels) to that in Burundi?
Offer a very short reply. 7.27. What is the ratio of the Aid flow from UN agencies (US$) in 2007 in Sub-Saharan Africa (developing only) to that in Burundi?
Your answer should be very brief. 2.54. What is the ratio of the Aid flow from UN agencies (US$) of 2008 in Sub-Saharan Africa (developing only) to that in Burundi?
Ensure brevity in your answer.  2.44. What is the ratio of the Aid flow from UN agencies (US$) of 2009 in Sub-Saharan Africa (developing only) to that in Burundi?
Your response must be concise. 4.3. What is the ratio of the Aid flow from UN agencies (US$) in 2010 in Sub-Saharan Africa (developing only) to that in Burundi?
Offer a terse response. 7.27. What is the difference between the highest and the second highest Aid flow from UN agencies (US$) of 2010?
Your response must be concise. 2.32e+06. What is the difference between the highest and the lowest Aid flow from UN agencies (US$) in 2007?
Offer a very short reply. 9.49e+06. What is the difference between the highest and the lowest Aid flow from UN agencies (US$) of 2008?
Your response must be concise. 3.05e+07. What is the difference between the highest and the lowest Aid flow from UN agencies (US$) of 2009?
Offer a terse response. 3.62e+07. What is the difference between the highest and the lowest Aid flow from UN agencies (US$) of 2010?
Your answer should be very brief. 4.30e+07. 